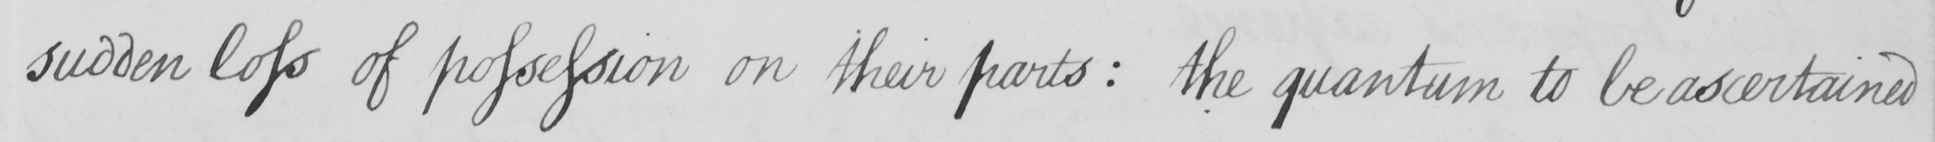Please transcribe the handwritten text in this image. sudden loss of possession on their parts :  the quantum to be ascertained 